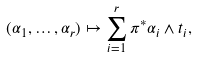Convert formula to latex. <formula><loc_0><loc_0><loc_500><loc_500>( \alpha _ { 1 } , \dots , \alpha _ { r } ) \mapsto \sum _ { i = 1 } ^ { r } \pi ^ { * } \alpha _ { i } \wedge t _ { i } ,</formula> 